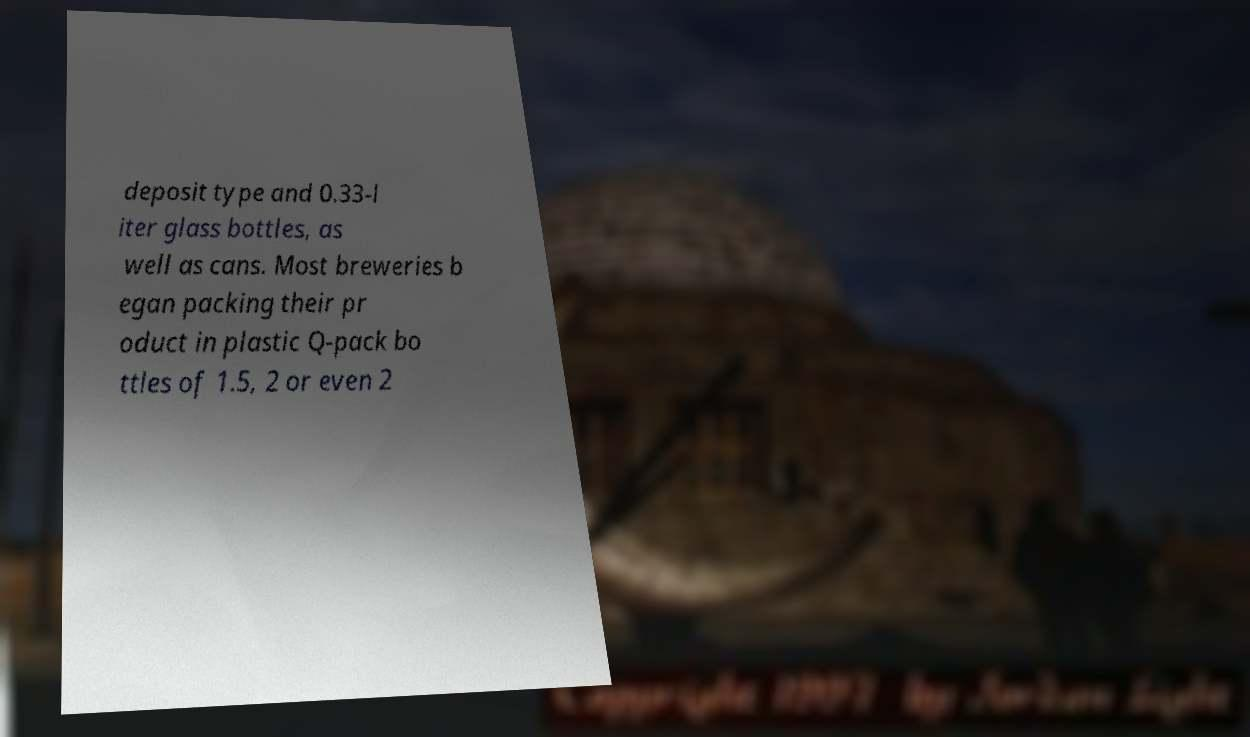Please identify and transcribe the text found in this image. deposit type and 0.33-l iter glass bottles, as well as cans. Most breweries b egan packing their pr oduct in plastic Q-pack bo ttles of 1.5, 2 or even 2 